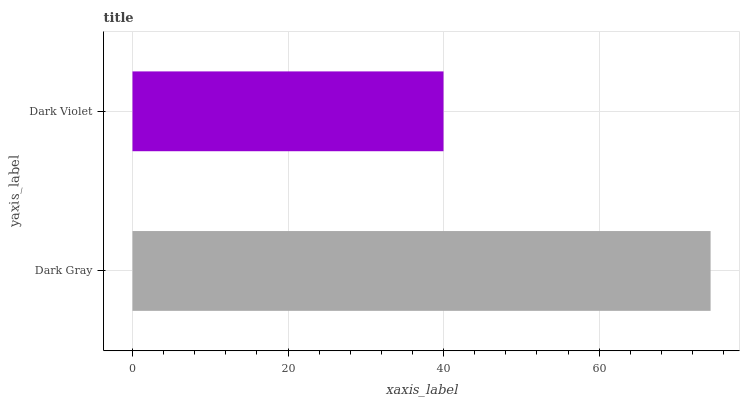Is Dark Violet the minimum?
Answer yes or no. Yes. Is Dark Gray the maximum?
Answer yes or no. Yes. Is Dark Violet the maximum?
Answer yes or no. No. Is Dark Gray greater than Dark Violet?
Answer yes or no. Yes. Is Dark Violet less than Dark Gray?
Answer yes or no. Yes. Is Dark Violet greater than Dark Gray?
Answer yes or no. No. Is Dark Gray less than Dark Violet?
Answer yes or no. No. Is Dark Gray the high median?
Answer yes or no. Yes. Is Dark Violet the low median?
Answer yes or no. Yes. Is Dark Violet the high median?
Answer yes or no. No. Is Dark Gray the low median?
Answer yes or no. No. 